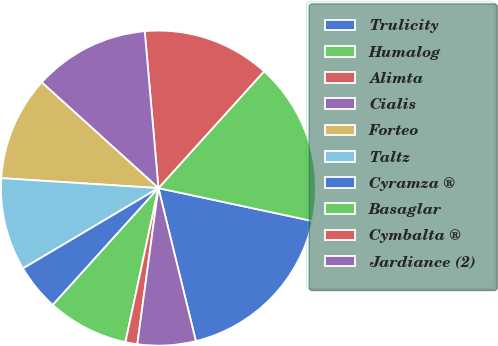<chart> <loc_0><loc_0><loc_500><loc_500><pie_chart><fcel>Trulicity<fcel>Humalog<fcel>Alimta<fcel>Cialis<fcel>Forteo<fcel>Taltz<fcel>Cyramza ®<fcel>Basaglar<fcel>Cymbalta ®<fcel>Jardiance (2)<nl><fcel>17.83%<fcel>16.65%<fcel>13.09%<fcel>11.9%<fcel>10.71%<fcel>9.53%<fcel>4.78%<fcel>8.34%<fcel>1.22%<fcel>5.96%<nl></chart> 